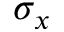<formula> <loc_0><loc_0><loc_500><loc_500>\sigma _ { x }</formula> 